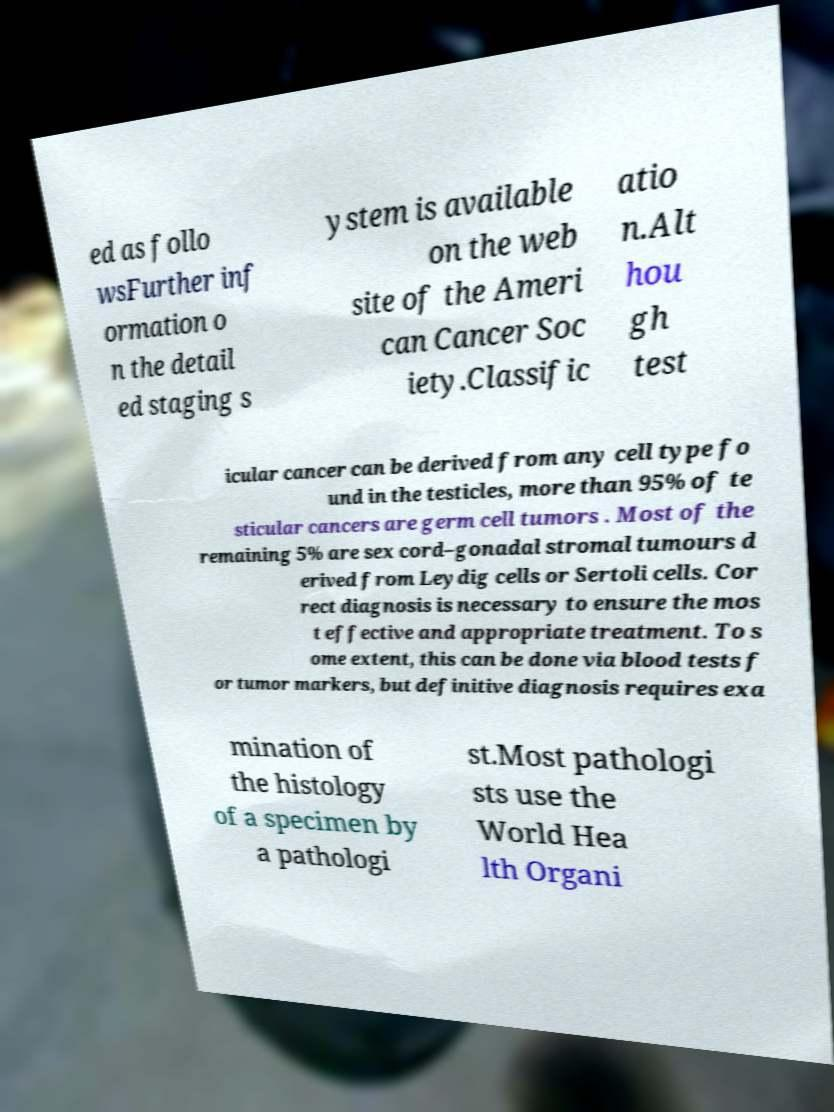There's text embedded in this image that I need extracted. Can you transcribe it verbatim? ed as follo wsFurther inf ormation o n the detail ed staging s ystem is available on the web site of the Ameri can Cancer Soc iety.Classific atio n.Alt hou gh test icular cancer can be derived from any cell type fo und in the testicles, more than 95% of te sticular cancers are germ cell tumors . Most of the remaining 5% are sex cord–gonadal stromal tumours d erived from Leydig cells or Sertoli cells. Cor rect diagnosis is necessary to ensure the mos t effective and appropriate treatment. To s ome extent, this can be done via blood tests f or tumor markers, but definitive diagnosis requires exa mination of the histology of a specimen by a pathologi st.Most pathologi sts use the World Hea lth Organi 